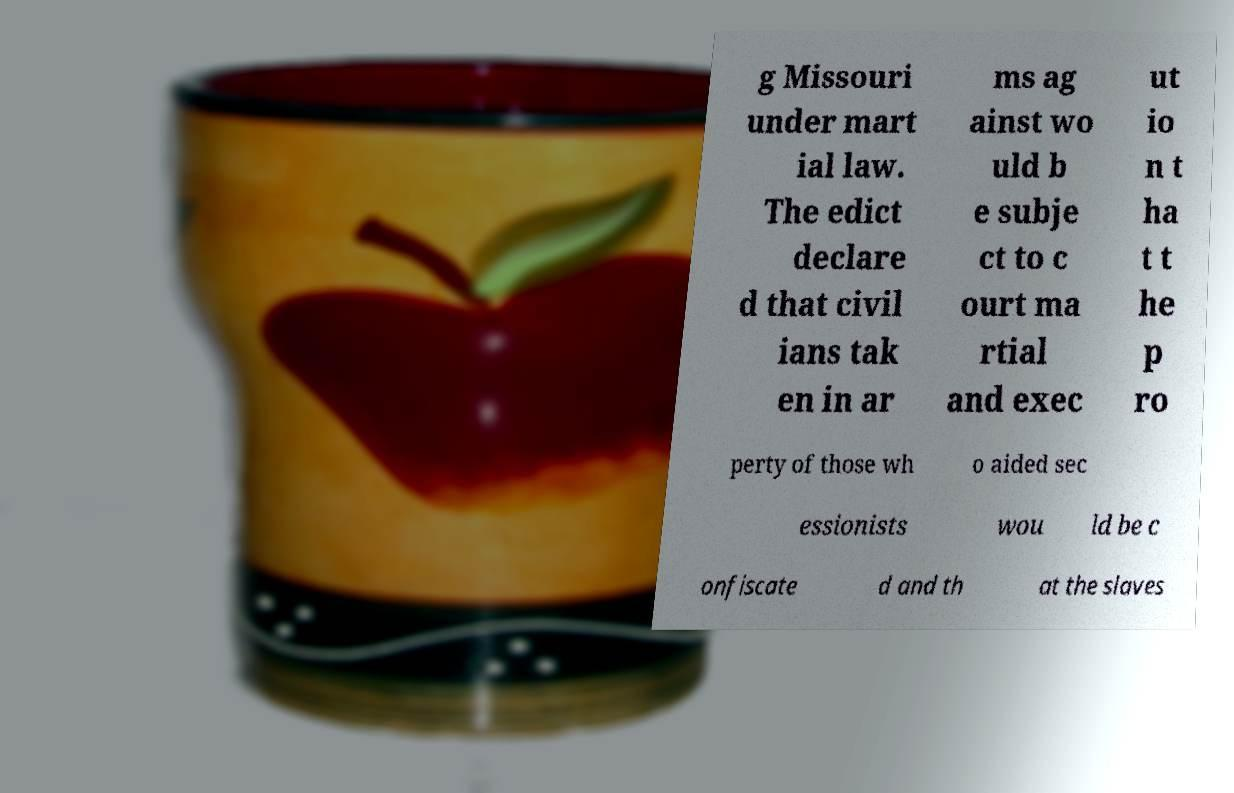There's text embedded in this image that I need extracted. Can you transcribe it verbatim? g Missouri under mart ial law. The edict declare d that civil ians tak en in ar ms ag ainst wo uld b e subje ct to c ourt ma rtial and exec ut io n t ha t t he p ro perty of those wh o aided sec essionists wou ld be c onfiscate d and th at the slaves 